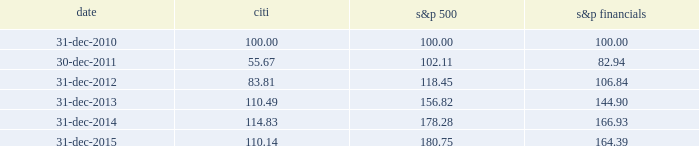Performance graph comparison of five-year cumulative total return the following graph and table compare the cumulative total return on citi 2019s common stock , which is listed on the nyse under the ticker symbol 201cc 201d and held by 81805 common stockholders of record as of january 31 , 2016 , with the cumulative total return of the s&p 500 index and the s&p financial index over the five-year period through december 31 , 2015 .
The graph and table assume that $ 100 was invested on december 31 , 2010 in citi 2019s common stock , the s&p 500 index and the s&p financial index , and that all dividends were reinvested .
Comparison of five-year cumulative total return for the years ended date citi s&p 500 financials .

What was the overall percentage growth of the cumulative total return for citi from 2010 to 2015? 
Computations: ((110.14 - 100) / 100)
Answer: 0.1014. 